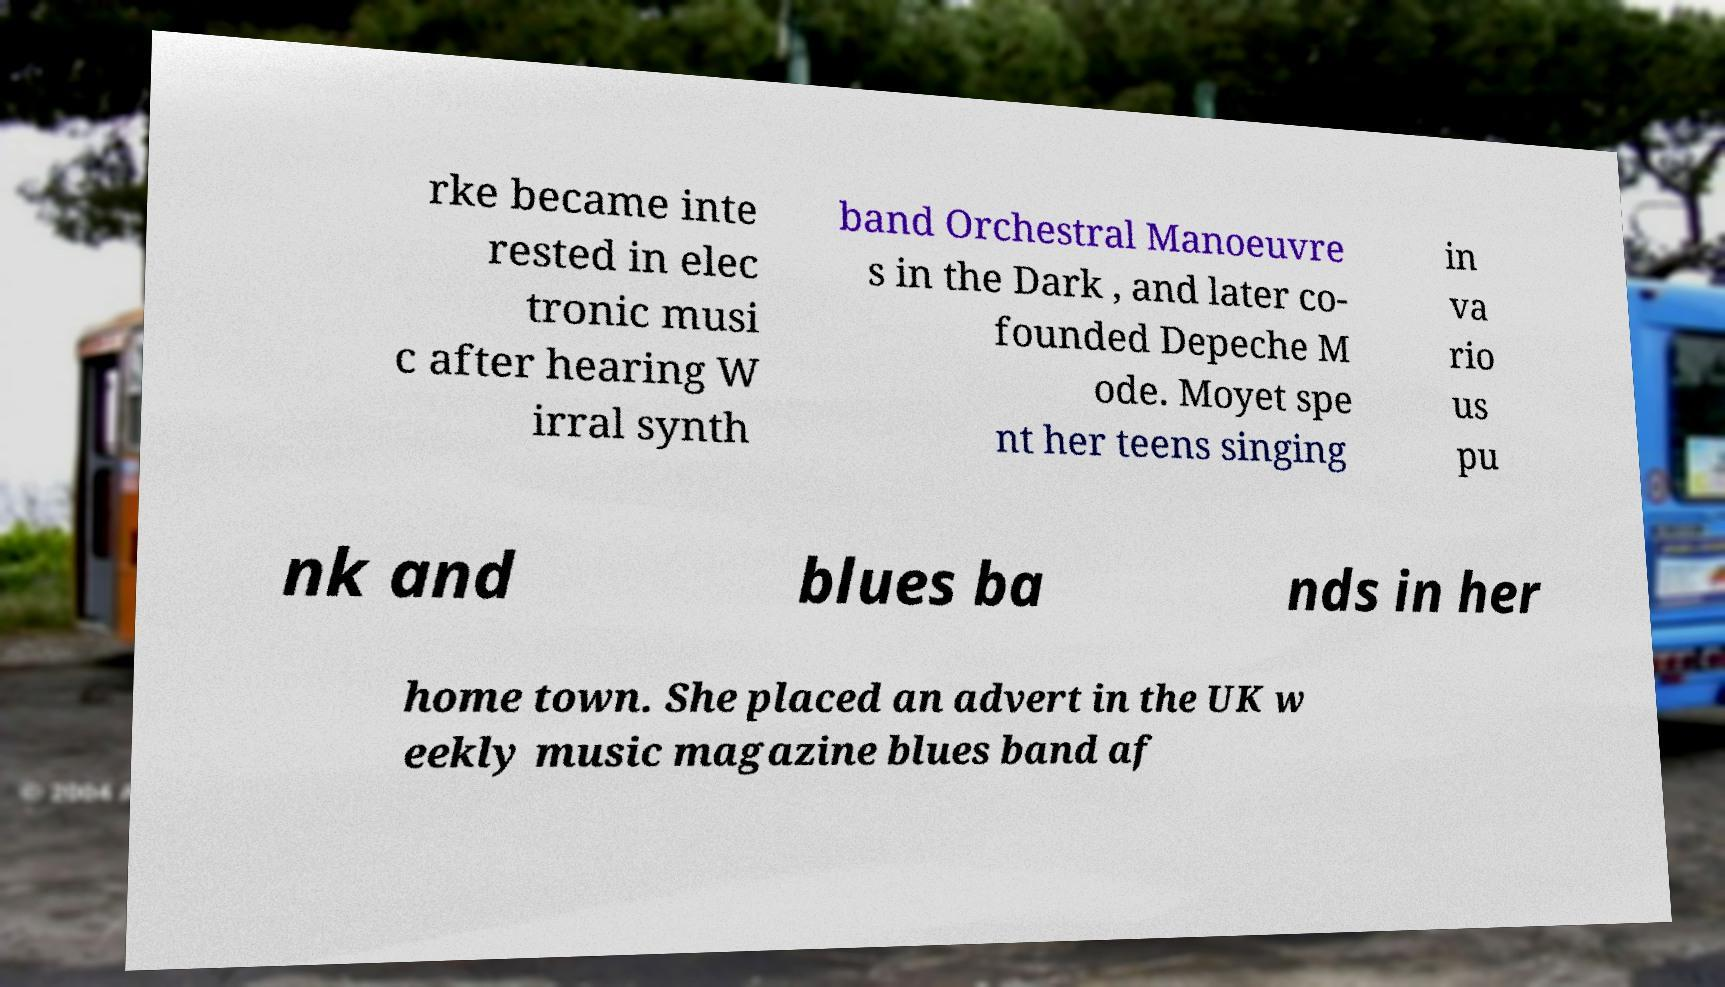What messages or text are displayed in this image? I need them in a readable, typed format. rke became inte rested in elec tronic musi c after hearing W irral synth band Orchestral Manoeuvre s in the Dark , and later co- founded Depeche M ode. Moyet spe nt her teens singing in va rio us pu nk and blues ba nds in her home town. She placed an advert in the UK w eekly music magazine blues band af 